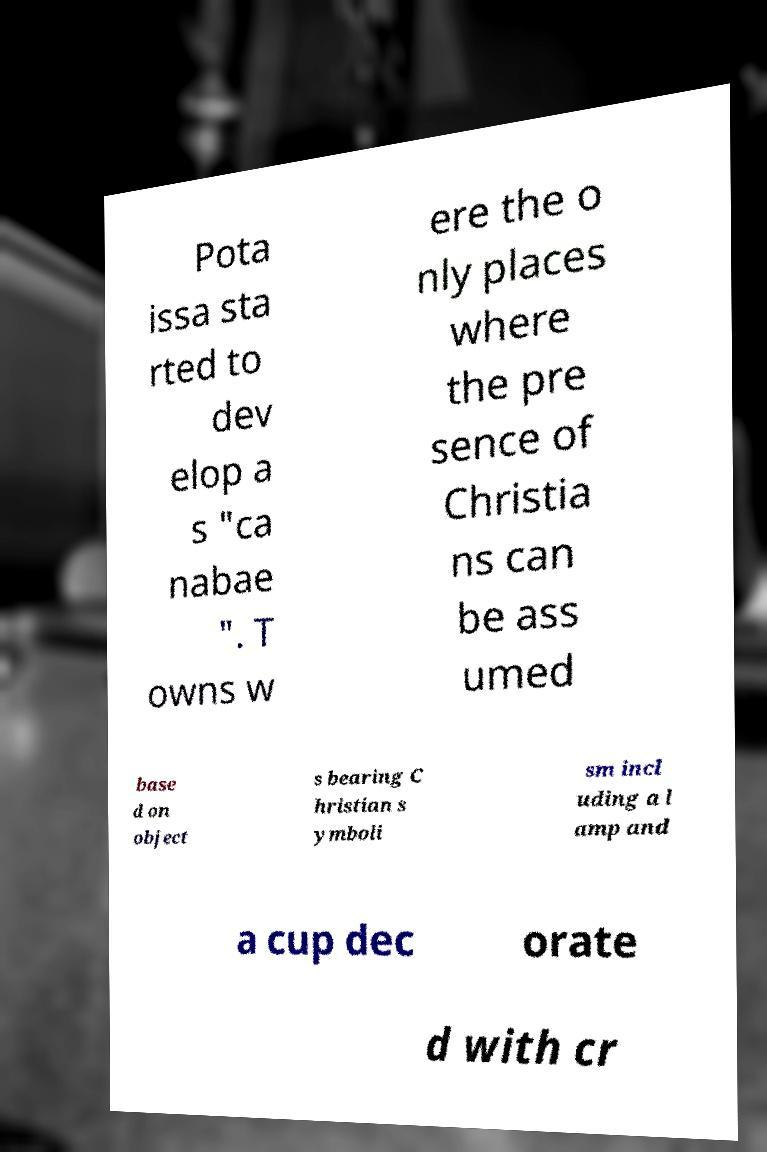For documentation purposes, I need the text within this image transcribed. Could you provide that? Pota issa sta rted to dev elop a s "ca nabae ". T owns w ere the o nly places where the pre sence of Christia ns can be ass umed base d on object s bearing C hristian s ymboli sm incl uding a l amp and a cup dec orate d with cr 